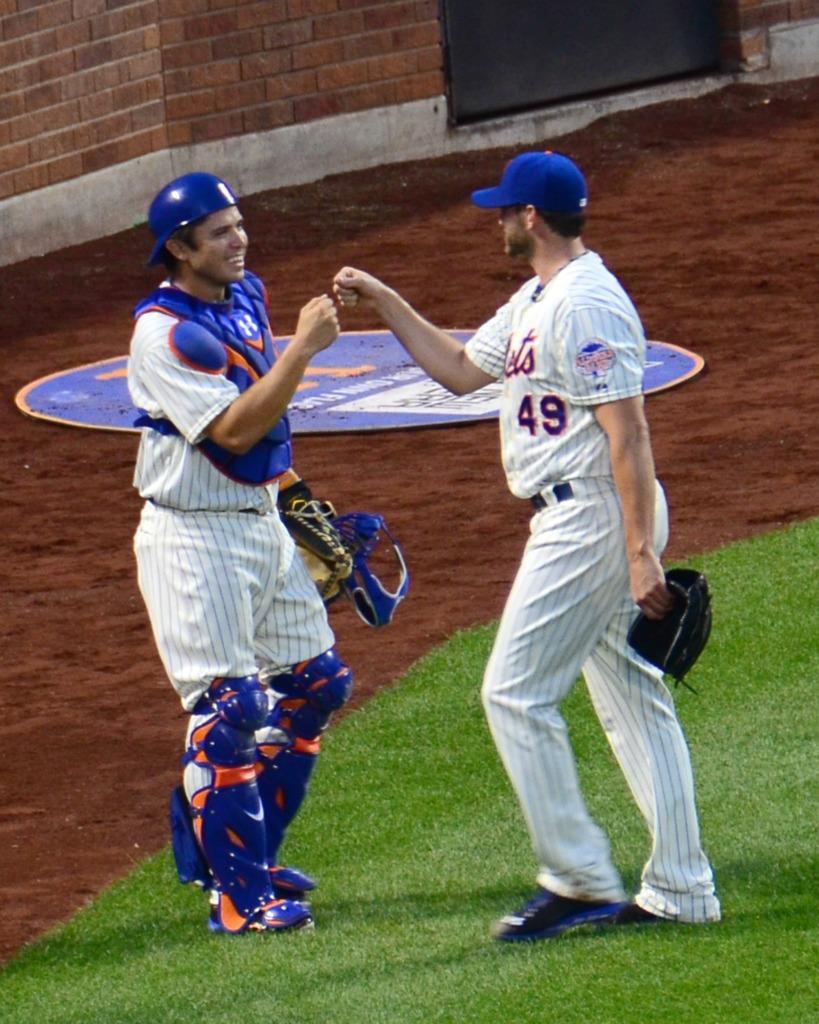What number is the player without a helmet?
Provide a short and direct response. 49. 